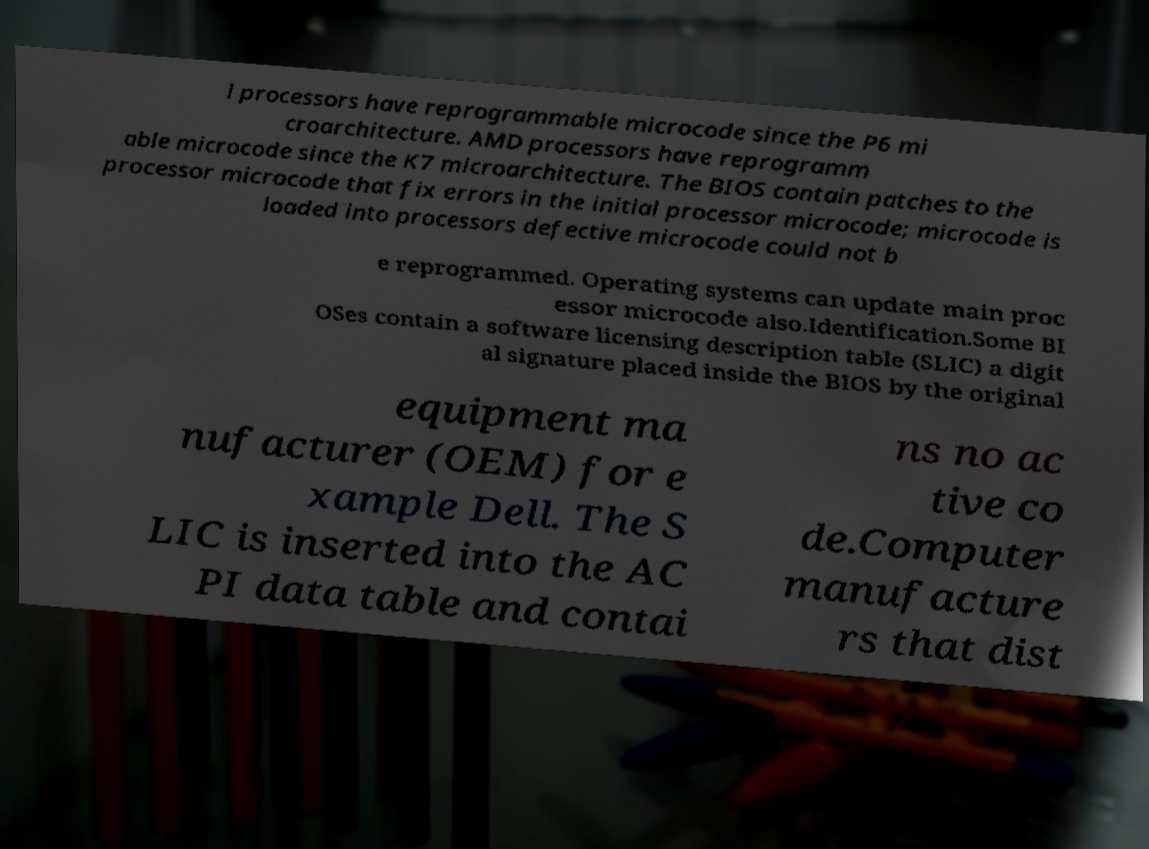Please identify and transcribe the text found in this image. l processors have reprogrammable microcode since the P6 mi croarchitecture. AMD processors have reprogramm able microcode since the K7 microarchitecture. The BIOS contain patches to the processor microcode that fix errors in the initial processor microcode; microcode is loaded into processors defective microcode could not b e reprogrammed. Operating systems can update main proc essor microcode also.Identification.Some BI OSes contain a software licensing description table (SLIC) a digit al signature placed inside the BIOS by the original equipment ma nufacturer (OEM) for e xample Dell. The S LIC is inserted into the AC PI data table and contai ns no ac tive co de.Computer manufacture rs that dist 